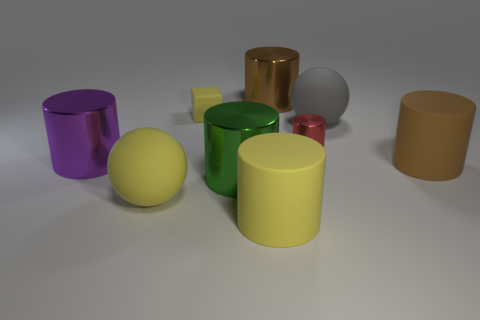What textures can be observed on the objects in the image? The objects present a variety of textures: the purple, yellow, green, and brown cylinders and the small red sphere have a reflective, glossy finish suggestive of a smooth surface, while the big brown and the gray ball seem to have a more subdued, matte texture, indicating a less reflective, possibly rougher surface. 